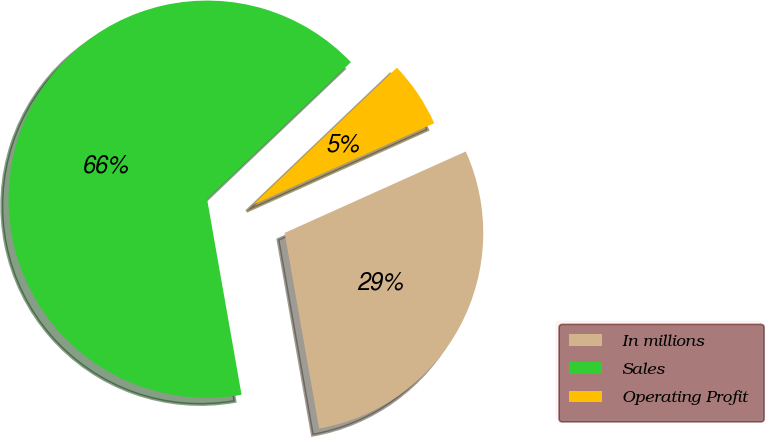Convert chart to OTSL. <chart><loc_0><loc_0><loc_500><loc_500><pie_chart><fcel>In millions<fcel>Sales<fcel>Operating Profit<nl><fcel>28.95%<fcel>65.66%<fcel>5.39%<nl></chart> 